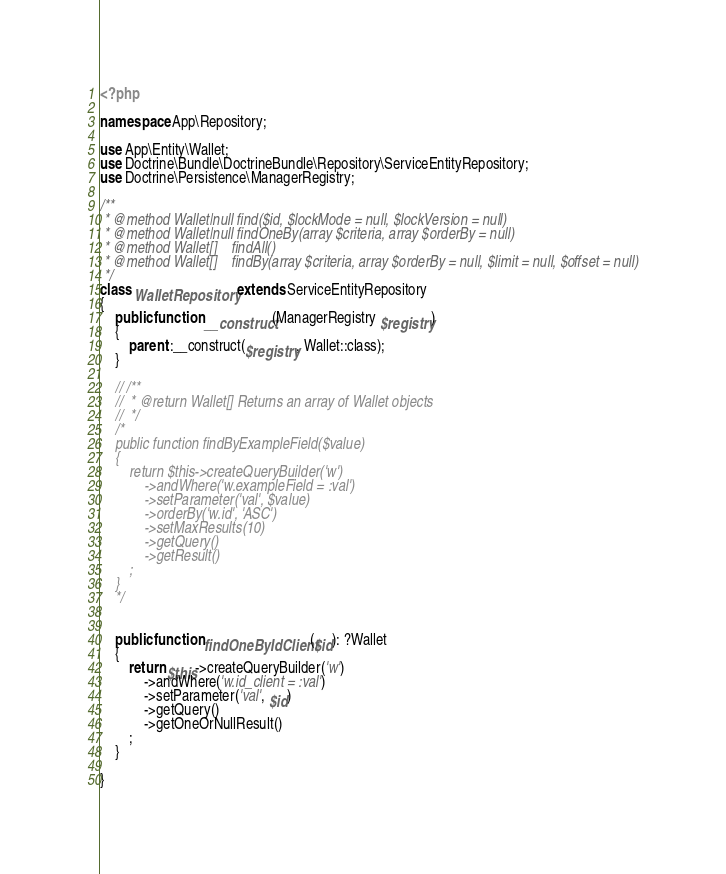Convert code to text. <code><loc_0><loc_0><loc_500><loc_500><_PHP_><?php

namespace App\Repository;

use App\Entity\Wallet;
use Doctrine\Bundle\DoctrineBundle\Repository\ServiceEntityRepository;
use Doctrine\Persistence\ManagerRegistry;

/**
 * @method Wallet|null find($id, $lockMode = null, $lockVersion = null)
 * @method Wallet|null findOneBy(array $criteria, array $orderBy = null)
 * @method Wallet[]    findAll()
 * @method Wallet[]    findBy(array $criteria, array $orderBy = null, $limit = null, $offset = null)
 */
class WalletRepository extends ServiceEntityRepository
{
    public function __construct(ManagerRegistry $registry)
    {
        parent::__construct($registry, Wallet::class);
    }

    // /**
    //  * @return Wallet[] Returns an array of Wallet objects
    //  */
    /*
    public function findByExampleField($value)
    {
        return $this->createQueryBuilder('w')
            ->andWhere('w.exampleField = :val')
            ->setParameter('val', $value)
            ->orderBy('w.id', 'ASC')
            ->setMaxResults(10)
            ->getQuery()
            ->getResult()
        ;
    }
    */

    
    public function findOneByIdClient($id): ?Wallet
    {
        return $this->createQueryBuilder('w')
            ->andWhere('w.id_client = :val')
            ->setParameter('val', $id)
            ->getQuery()
            ->getOneOrNullResult()
        ;
    }
    
}
</code> 